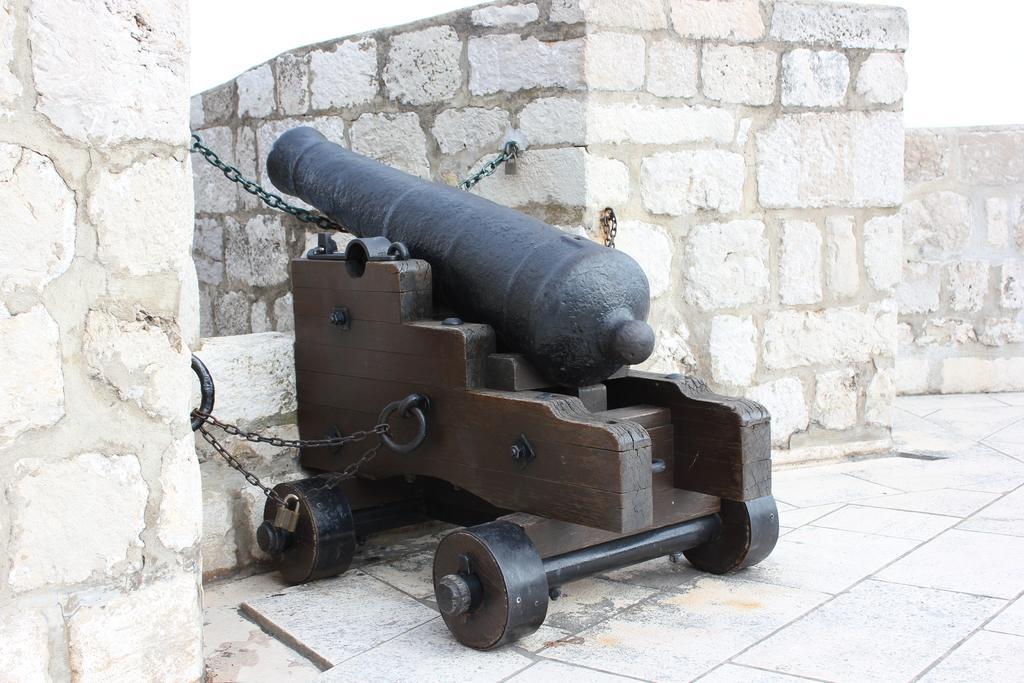Could you give a brief overview of what you see in this image? In this image I can see in the middle it looks like a cannon, on the right side there are walls. At the top it is the sky. 